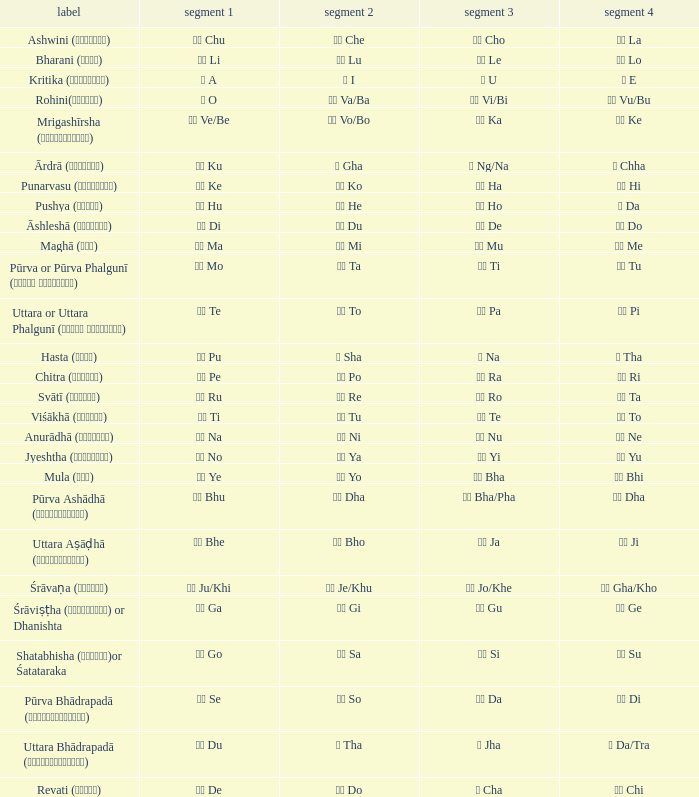What is the Name of ङ ng/na? Ārdrā (आर्द्रा). 